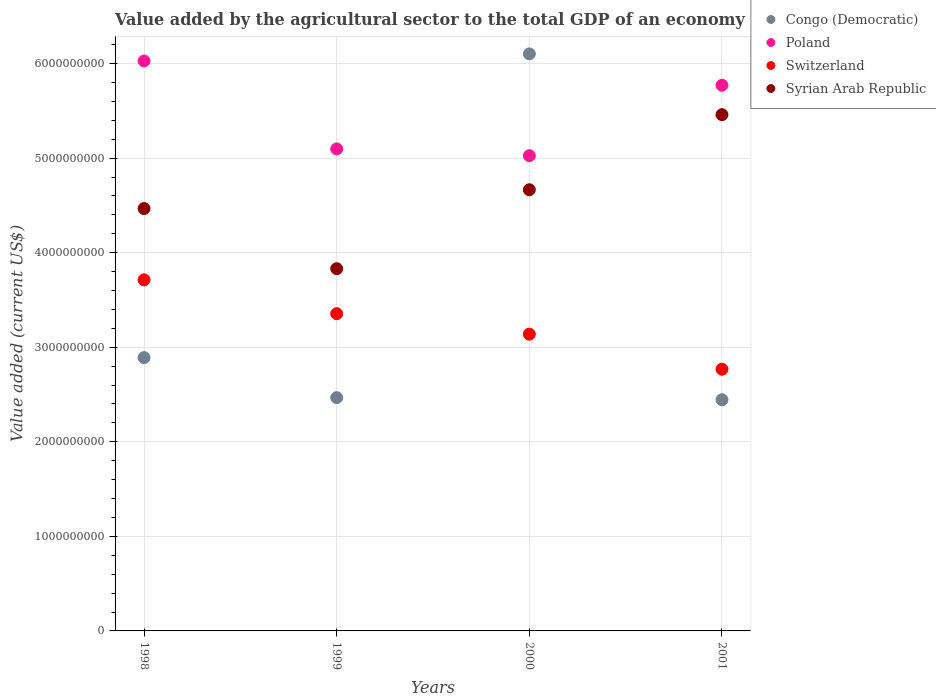Is the number of dotlines equal to the number of legend labels?
Your response must be concise. Yes. What is the value added by the agricultural sector to the total GDP in Switzerland in 1998?
Give a very brief answer. 3.71e+09. Across all years, what is the maximum value added by the agricultural sector to the total GDP in Congo (Democratic)?
Offer a very short reply. 6.10e+09. Across all years, what is the minimum value added by the agricultural sector to the total GDP in Syrian Arab Republic?
Make the answer very short. 3.83e+09. In which year was the value added by the agricultural sector to the total GDP in Switzerland minimum?
Offer a very short reply. 2001. What is the total value added by the agricultural sector to the total GDP in Switzerland in the graph?
Make the answer very short. 1.30e+1. What is the difference between the value added by the agricultural sector to the total GDP in Syrian Arab Republic in 2000 and that in 2001?
Give a very brief answer. -7.94e+08. What is the difference between the value added by the agricultural sector to the total GDP in Poland in 1998 and the value added by the agricultural sector to the total GDP in Congo (Democratic) in 2001?
Keep it short and to the point. 3.58e+09. What is the average value added by the agricultural sector to the total GDP in Poland per year?
Give a very brief answer. 5.48e+09. In the year 2000, what is the difference between the value added by the agricultural sector to the total GDP in Congo (Democratic) and value added by the agricultural sector to the total GDP in Syrian Arab Republic?
Provide a succinct answer. 1.44e+09. What is the ratio of the value added by the agricultural sector to the total GDP in Syrian Arab Republic in 1998 to that in 2001?
Ensure brevity in your answer.  0.82. Is the value added by the agricultural sector to the total GDP in Syrian Arab Republic in 1998 less than that in 1999?
Give a very brief answer. No. Is the difference between the value added by the agricultural sector to the total GDP in Congo (Democratic) in 1998 and 2001 greater than the difference between the value added by the agricultural sector to the total GDP in Syrian Arab Republic in 1998 and 2001?
Your answer should be compact. Yes. What is the difference between the highest and the second highest value added by the agricultural sector to the total GDP in Poland?
Ensure brevity in your answer.  2.57e+08. What is the difference between the highest and the lowest value added by the agricultural sector to the total GDP in Syrian Arab Republic?
Your answer should be very brief. 1.63e+09. In how many years, is the value added by the agricultural sector to the total GDP in Poland greater than the average value added by the agricultural sector to the total GDP in Poland taken over all years?
Provide a succinct answer. 2. Is the sum of the value added by the agricultural sector to the total GDP in Congo (Democratic) in 2000 and 2001 greater than the maximum value added by the agricultural sector to the total GDP in Poland across all years?
Provide a succinct answer. Yes. Is the value added by the agricultural sector to the total GDP in Congo (Democratic) strictly greater than the value added by the agricultural sector to the total GDP in Syrian Arab Republic over the years?
Your answer should be compact. No. Is the value added by the agricultural sector to the total GDP in Congo (Democratic) strictly less than the value added by the agricultural sector to the total GDP in Poland over the years?
Make the answer very short. No. How many dotlines are there?
Offer a terse response. 4. Are the values on the major ticks of Y-axis written in scientific E-notation?
Ensure brevity in your answer.  No. Does the graph contain any zero values?
Ensure brevity in your answer.  No. Where does the legend appear in the graph?
Ensure brevity in your answer.  Top right. How many legend labels are there?
Your answer should be compact. 4. What is the title of the graph?
Offer a terse response. Value added by the agricultural sector to the total GDP of an economy. Does "Cayman Islands" appear as one of the legend labels in the graph?
Give a very brief answer. No. What is the label or title of the X-axis?
Ensure brevity in your answer.  Years. What is the label or title of the Y-axis?
Make the answer very short. Value added (current US$). What is the Value added (current US$) in Congo (Democratic) in 1998?
Make the answer very short. 2.89e+09. What is the Value added (current US$) in Poland in 1998?
Your answer should be compact. 6.03e+09. What is the Value added (current US$) of Switzerland in 1998?
Make the answer very short. 3.71e+09. What is the Value added (current US$) in Syrian Arab Republic in 1998?
Keep it short and to the point. 4.47e+09. What is the Value added (current US$) of Congo (Democratic) in 1999?
Provide a succinct answer. 2.47e+09. What is the Value added (current US$) of Poland in 1999?
Give a very brief answer. 5.10e+09. What is the Value added (current US$) in Switzerland in 1999?
Make the answer very short. 3.36e+09. What is the Value added (current US$) of Syrian Arab Republic in 1999?
Provide a succinct answer. 3.83e+09. What is the Value added (current US$) of Congo (Democratic) in 2000?
Make the answer very short. 6.10e+09. What is the Value added (current US$) of Poland in 2000?
Keep it short and to the point. 5.03e+09. What is the Value added (current US$) of Switzerland in 2000?
Provide a succinct answer. 3.14e+09. What is the Value added (current US$) in Syrian Arab Republic in 2000?
Your answer should be compact. 4.67e+09. What is the Value added (current US$) in Congo (Democratic) in 2001?
Offer a terse response. 2.44e+09. What is the Value added (current US$) in Poland in 2001?
Your answer should be compact. 5.77e+09. What is the Value added (current US$) of Switzerland in 2001?
Give a very brief answer. 2.77e+09. What is the Value added (current US$) of Syrian Arab Republic in 2001?
Make the answer very short. 5.46e+09. Across all years, what is the maximum Value added (current US$) in Congo (Democratic)?
Make the answer very short. 6.10e+09. Across all years, what is the maximum Value added (current US$) of Poland?
Provide a succinct answer. 6.03e+09. Across all years, what is the maximum Value added (current US$) of Switzerland?
Keep it short and to the point. 3.71e+09. Across all years, what is the maximum Value added (current US$) in Syrian Arab Republic?
Ensure brevity in your answer.  5.46e+09. Across all years, what is the minimum Value added (current US$) of Congo (Democratic)?
Your answer should be compact. 2.44e+09. Across all years, what is the minimum Value added (current US$) in Poland?
Offer a terse response. 5.03e+09. Across all years, what is the minimum Value added (current US$) in Switzerland?
Your response must be concise. 2.77e+09. Across all years, what is the minimum Value added (current US$) in Syrian Arab Republic?
Give a very brief answer. 3.83e+09. What is the total Value added (current US$) in Congo (Democratic) in the graph?
Offer a very short reply. 1.39e+1. What is the total Value added (current US$) in Poland in the graph?
Provide a succinct answer. 2.19e+1. What is the total Value added (current US$) in Switzerland in the graph?
Make the answer very short. 1.30e+1. What is the total Value added (current US$) in Syrian Arab Republic in the graph?
Give a very brief answer. 1.84e+1. What is the difference between the Value added (current US$) of Congo (Democratic) in 1998 and that in 1999?
Ensure brevity in your answer.  4.23e+08. What is the difference between the Value added (current US$) in Poland in 1998 and that in 1999?
Ensure brevity in your answer.  9.30e+08. What is the difference between the Value added (current US$) of Switzerland in 1998 and that in 1999?
Provide a succinct answer. 3.58e+08. What is the difference between the Value added (current US$) of Syrian Arab Republic in 1998 and that in 1999?
Offer a very short reply. 6.36e+08. What is the difference between the Value added (current US$) of Congo (Democratic) in 1998 and that in 2000?
Ensure brevity in your answer.  -3.21e+09. What is the difference between the Value added (current US$) of Poland in 1998 and that in 2000?
Your answer should be very brief. 1.00e+09. What is the difference between the Value added (current US$) in Switzerland in 1998 and that in 2000?
Offer a terse response. 5.74e+08. What is the difference between the Value added (current US$) in Syrian Arab Republic in 1998 and that in 2000?
Your response must be concise. -1.99e+08. What is the difference between the Value added (current US$) in Congo (Democratic) in 1998 and that in 2001?
Ensure brevity in your answer.  4.45e+08. What is the difference between the Value added (current US$) in Poland in 1998 and that in 2001?
Your answer should be very brief. 2.57e+08. What is the difference between the Value added (current US$) of Switzerland in 1998 and that in 2001?
Provide a short and direct response. 9.45e+08. What is the difference between the Value added (current US$) in Syrian Arab Republic in 1998 and that in 2001?
Your answer should be very brief. -9.93e+08. What is the difference between the Value added (current US$) in Congo (Democratic) in 1999 and that in 2000?
Keep it short and to the point. -3.64e+09. What is the difference between the Value added (current US$) in Poland in 1999 and that in 2000?
Give a very brief answer. 7.14e+07. What is the difference between the Value added (current US$) of Switzerland in 1999 and that in 2000?
Ensure brevity in your answer.  2.17e+08. What is the difference between the Value added (current US$) of Syrian Arab Republic in 1999 and that in 2000?
Offer a terse response. -8.35e+08. What is the difference between the Value added (current US$) of Congo (Democratic) in 1999 and that in 2001?
Your response must be concise. 2.21e+07. What is the difference between the Value added (current US$) of Poland in 1999 and that in 2001?
Give a very brief answer. -6.73e+08. What is the difference between the Value added (current US$) of Switzerland in 1999 and that in 2001?
Provide a succinct answer. 5.87e+08. What is the difference between the Value added (current US$) of Syrian Arab Republic in 1999 and that in 2001?
Provide a short and direct response. -1.63e+09. What is the difference between the Value added (current US$) of Congo (Democratic) in 2000 and that in 2001?
Your answer should be very brief. 3.66e+09. What is the difference between the Value added (current US$) of Poland in 2000 and that in 2001?
Your answer should be very brief. -7.45e+08. What is the difference between the Value added (current US$) in Switzerland in 2000 and that in 2001?
Offer a very short reply. 3.71e+08. What is the difference between the Value added (current US$) in Syrian Arab Republic in 2000 and that in 2001?
Your answer should be compact. -7.94e+08. What is the difference between the Value added (current US$) in Congo (Democratic) in 1998 and the Value added (current US$) in Poland in 1999?
Offer a terse response. -2.21e+09. What is the difference between the Value added (current US$) in Congo (Democratic) in 1998 and the Value added (current US$) in Switzerland in 1999?
Provide a short and direct response. -4.65e+08. What is the difference between the Value added (current US$) in Congo (Democratic) in 1998 and the Value added (current US$) in Syrian Arab Republic in 1999?
Your answer should be compact. -9.41e+08. What is the difference between the Value added (current US$) of Poland in 1998 and the Value added (current US$) of Switzerland in 1999?
Offer a terse response. 2.67e+09. What is the difference between the Value added (current US$) in Poland in 1998 and the Value added (current US$) in Syrian Arab Republic in 1999?
Keep it short and to the point. 2.20e+09. What is the difference between the Value added (current US$) in Switzerland in 1998 and the Value added (current US$) in Syrian Arab Republic in 1999?
Make the answer very short. -1.18e+08. What is the difference between the Value added (current US$) in Congo (Democratic) in 1998 and the Value added (current US$) in Poland in 2000?
Make the answer very short. -2.14e+09. What is the difference between the Value added (current US$) in Congo (Democratic) in 1998 and the Value added (current US$) in Switzerland in 2000?
Keep it short and to the point. -2.48e+08. What is the difference between the Value added (current US$) of Congo (Democratic) in 1998 and the Value added (current US$) of Syrian Arab Republic in 2000?
Your response must be concise. -1.78e+09. What is the difference between the Value added (current US$) in Poland in 1998 and the Value added (current US$) in Switzerland in 2000?
Offer a terse response. 2.89e+09. What is the difference between the Value added (current US$) of Poland in 1998 and the Value added (current US$) of Syrian Arab Republic in 2000?
Provide a short and direct response. 1.36e+09. What is the difference between the Value added (current US$) of Switzerland in 1998 and the Value added (current US$) of Syrian Arab Republic in 2000?
Offer a terse response. -9.53e+08. What is the difference between the Value added (current US$) of Congo (Democratic) in 1998 and the Value added (current US$) of Poland in 2001?
Keep it short and to the point. -2.88e+09. What is the difference between the Value added (current US$) of Congo (Democratic) in 1998 and the Value added (current US$) of Switzerland in 2001?
Give a very brief answer. 1.22e+08. What is the difference between the Value added (current US$) in Congo (Democratic) in 1998 and the Value added (current US$) in Syrian Arab Republic in 2001?
Ensure brevity in your answer.  -2.57e+09. What is the difference between the Value added (current US$) in Poland in 1998 and the Value added (current US$) in Switzerland in 2001?
Provide a succinct answer. 3.26e+09. What is the difference between the Value added (current US$) of Poland in 1998 and the Value added (current US$) of Syrian Arab Republic in 2001?
Offer a terse response. 5.68e+08. What is the difference between the Value added (current US$) of Switzerland in 1998 and the Value added (current US$) of Syrian Arab Republic in 2001?
Your answer should be very brief. -1.75e+09. What is the difference between the Value added (current US$) of Congo (Democratic) in 1999 and the Value added (current US$) of Poland in 2000?
Keep it short and to the point. -2.56e+09. What is the difference between the Value added (current US$) of Congo (Democratic) in 1999 and the Value added (current US$) of Switzerland in 2000?
Your answer should be compact. -6.71e+08. What is the difference between the Value added (current US$) in Congo (Democratic) in 1999 and the Value added (current US$) in Syrian Arab Republic in 2000?
Offer a very short reply. -2.20e+09. What is the difference between the Value added (current US$) of Poland in 1999 and the Value added (current US$) of Switzerland in 2000?
Offer a terse response. 1.96e+09. What is the difference between the Value added (current US$) of Poland in 1999 and the Value added (current US$) of Syrian Arab Republic in 2000?
Your answer should be compact. 4.32e+08. What is the difference between the Value added (current US$) of Switzerland in 1999 and the Value added (current US$) of Syrian Arab Republic in 2000?
Offer a very short reply. -1.31e+09. What is the difference between the Value added (current US$) in Congo (Democratic) in 1999 and the Value added (current US$) in Poland in 2001?
Give a very brief answer. -3.30e+09. What is the difference between the Value added (current US$) of Congo (Democratic) in 1999 and the Value added (current US$) of Switzerland in 2001?
Give a very brief answer. -3.01e+08. What is the difference between the Value added (current US$) of Congo (Democratic) in 1999 and the Value added (current US$) of Syrian Arab Republic in 2001?
Your response must be concise. -2.99e+09. What is the difference between the Value added (current US$) in Poland in 1999 and the Value added (current US$) in Switzerland in 2001?
Provide a short and direct response. 2.33e+09. What is the difference between the Value added (current US$) in Poland in 1999 and the Value added (current US$) in Syrian Arab Republic in 2001?
Provide a succinct answer. -3.62e+08. What is the difference between the Value added (current US$) of Switzerland in 1999 and the Value added (current US$) of Syrian Arab Republic in 2001?
Make the answer very short. -2.10e+09. What is the difference between the Value added (current US$) in Congo (Democratic) in 2000 and the Value added (current US$) in Poland in 2001?
Keep it short and to the point. 3.32e+08. What is the difference between the Value added (current US$) of Congo (Democratic) in 2000 and the Value added (current US$) of Switzerland in 2001?
Provide a short and direct response. 3.33e+09. What is the difference between the Value added (current US$) in Congo (Democratic) in 2000 and the Value added (current US$) in Syrian Arab Republic in 2001?
Offer a very short reply. 6.43e+08. What is the difference between the Value added (current US$) in Poland in 2000 and the Value added (current US$) in Switzerland in 2001?
Your answer should be very brief. 2.26e+09. What is the difference between the Value added (current US$) of Poland in 2000 and the Value added (current US$) of Syrian Arab Republic in 2001?
Offer a very short reply. -4.34e+08. What is the difference between the Value added (current US$) of Switzerland in 2000 and the Value added (current US$) of Syrian Arab Republic in 2001?
Your answer should be very brief. -2.32e+09. What is the average Value added (current US$) in Congo (Democratic) per year?
Provide a succinct answer. 3.48e+09. What is the average Value added (current US$) in Poland per year?
Ensure brevity in your answer.  5.48e+09. What is the average Value added (current US$) in Switzerland per year?
Your response must be concise. 3.24e+09. What is the average Value added (current US$) in Syrian Arab Republic per year?
Your answer should be compact. 4.61e+09. In the year 1998, what is the difference between the Value added (current US$) in Congo (Democratic) and Value added (current US$) in Poland?
Offer a very short reply. -3.14e+09. In the year 1998, what is the difference between the Value added (current US$) in Congo (Democratic) and Value added (current US$) in Switzerland?
Keep it short and to the point. -8.23e+08. In the year 1998, what is the difference between the Value added (current US$) in Congo (Democratic) and Value added (current US$) in Syrian Arab Republic?
Your answer should be compact. -1.58e+09. In the year 1998, what is the difference between the Value added (current US$) in Poland and Value added (current US$) in Switzerland?
Your answer should be very brief. 2.31e+09. In the year 1998, what is the difference between the Value added (current US$) in Poland and Value added (current US$) in Syrian Arab Republic?
Provide a succinct answer. 1.56e+09. In the year 1998, what is the difference between the Value added (current US$) of Switzerland and Value added (current US$) of Syrian Arab Republic?
Keep it short and to the point. -7.54e+08. In the year 1999, what is the difference between the Value added (current US$) in Congo (Democratic) and Value added (current US$) in Poland?
Provide a succinct answer. -2.63e+09. In the year 1999, what is the difference between the Value added (current US$) in Congo (Democratic) and Value added (current US$) in Switzerland?
Your response must be concise. -8.88e+08. In the year 1999, what is the difference between the Value added (current US$) in Congo (Democratic) and Value added (current US$) in Syrian Arab Republic?
Provide a succinct answer. -1.36e+09. In the year 1999, what is the difference between the Value added (current US$) in Poland and Value added (current US$) in Switzerland?
Ensure brevity in your answer.  1.74e+09. In the year 1999, what is the difference between the Value added (current US$) in Poland and Value added (current US$) in Syrian Arab Republic?
Make the answer very short. 1.27e+09. In the year 1999, what is the difference between the Value added (current US$) in Switzerland and Value added (current US$) in Syrian Arab Republic?
Offer a terse response. -4.76e+08. In the year 2000, what is the difference between the Value added (current US$) in Congo (Democratic) and Value added (current US$) in Poland?
Give a very brief answer. 1.08e+09. In the year 2000, what is the difference between the Value added (current US$) in Congo (Democratic) and Value added (current US$) in Switzerland?
Your response must be concise. 2.96e+09. In the year 2000, what is the difference between the Value added (current US$) in Congo (Democratic) and Value added (current US$) in Syrian Arab Republic?
Make the answer very short. 1.44e+09. In the year 2000, what is the difference between the Value added (current US$) in Poland and Value added (current US$) in Switzerland?
Offer a very short reply. 1.89e+09. In the year 2000, what is the difference between the Value added (current US$) of Poland and Value added (current US$) of Syrian Arab Republic?
Ensure brevity in your answer.  3.60e+08. In the year 2000, what is the difference between the Value added (current US$) of Switzerland and Value added (current US$) of Syrian Arab Republic?
Make the answer very short. -1.53e+09. In the year 2001, what is the difference between the Value added (current US$) of Congo (Democratic) and Value added (current US$) of Poland?
Offer a very short reply. -3.33e+09. In the year 2001, what is the difference between the Value added (current US$) in Congo (Democratic) and Value added (current US$) in Switzerland?
Offer a terse response. -3.23e+08. In the year 2001, what is the difference between the Value added (current US$) in Congo (Democratic) and Value added (current US$) in Syrian Arab Republic?
Ensure brevity in your answer.  -3.01e+09. In the year 2001, what is the difference between the Value added (current US$) in Poland and Value added (current US$) in Switzerland?
Offer a terse response. 3.00e+09. In the year 2001, what is the difference between the Value added (current US$) in Poland and Value added (current US$) in Syrian Arab Republic?
Your answer should be compact. 3.11e+08. In the year 2001, what is the difference between the Value added (current US$) in Switzerland and Value added (current US$) in Syrian Arab Republic?
Offer a terse response. -2.69e+09. What is the ratio of the Value added (current US$) in Congo (Democratic) in 1998 to that in 1999?
Give a very brief answer. 1.17. What is the ratio of the Value added (current US$) in Poland in 1998 to that in 1999?
Give a very brief answer. 1.18. What is the ratio of the Value added (current US$) of Switzerland in 1998 to that in 1999?
Give a very brief answer. 1.11. What is the ratio of the Value added (current US$) in Syrian Arab Republic in 1998 to that in 1999?
Keep it short and to the point. 1.17. What is the ratio of the Value added (current US$) in Congo (Democratic) in 1998 to that in 2000?
Ensure brevity in your answer.  0.47. What is the ratio of the Value added (current US$) of Poland in 1998 to that in 2000?
Your answer should be compact. 1.2. What is the ratio of the Value added (current US$) of Switzerland in 1998 to that in 2000?
Offer a very short reply. 1.18. What is the ratio of the Value added (current US$) in Syrian Arab Republic in 1998 to that in 2000?
Ensure brevity in your answer.  0.96. What is the ratio of the Value added (current US$) of Congo (Democratic) in 1998 to that in 2001?
Offer a terse response. 1.18. What is the ratio of the Value added (current US$) of Poland in 1998 to that in 2001?
Give a very brief answer. 1.04. What is the ratio of the Value added (current US$) of Switzerland in 1998 to that in 2001?
Offer a very short reply. 1.34. What is the ratio of the Value added (current US$) in Syrian Arab Republic in 1998 to that in 2001?
Give a very brief answer. 0.82. What is the ratio of the Value added (current US$) of Congo (Democratic) in 1999 to that in 2000?
Offer a terse response. 0.4. What is the ratio of the Value added (current US$) of Poland in 1999 to that in 2000?
Your answer should be compact. 1.01. What is the ratio of the Value added (current US$) in Switzerland in 1999 to that in 2000?
Offer a very short reply. 1.07. What is the ratio of the Value added (current US$) of Syrian Arab Republic in 1999 to that in 2000?
Offer a very short reply. 0.82. What is the ratio of the Value added (current US$) in Poland in 1999 to that in 2001?
Your response must be concise. 0.88. What is the ratio of the Value added (current US$) in Switzerland in 1999 to that in 2001?
Offer a terse response. 1.21. What is the ratio of the Value added (current US$) of Syrian Arab Republic in 1999 to that in 2001?
Your answer should be very brief. 0.7. What is the ratio of the Value added (current US$) of Congo (Democratic) in 2000 to that in 2001?
Ensure brevity in your answer.  2.5. What is the ratio of the Value added (current US$) in Poland in 2000 to that in 2001?
Your answer should be very brief. 0.87. What is the ratio of the Value added (current US$) in Switzerland in 2000 to that in 2001?
Your answer should be compact. 1.13. What is the ratio of the Value added (current US$) in Syrian Arab Republic in 2000 to that in 2001?
Your answer should be compact. 0.85. What is the difference between the highest and the second highest Value added (current US$) of Congo (Democratic)?
Your answer should be compact. 3.21e+09. What is the difference between the highest and the second highest Value added (current US$) in Poland?
Your answer should be very brief. 2.57e+08. What is the difference between the highest and the second highest Value added (current US$) of Switzerland?
Make the answer very short. 3.58e+08. What is the difference between the highest and the second highest Value added (current US$) of Syrian Arab Republic?
Your answer should be very brief. 7.94e+08. What is the difference between the highest and the lowest Value added (current US$) in Congo (Democratic)?
Keep it short and to the point. 3.66e+09. What is the difference between the highest and the lowest Value added (current US$) in Poland?
Your answer should be very brief. 1.00e+09. What is the difference between the highest and the lowest Value added (current US$) of Switzerland?
Make the answer very short. 9.45e+08. What is the difference between the highest and the lowest Value added (current US$) in Syrian Arab Republic?
Make the answer very short. 1.63e+09. 